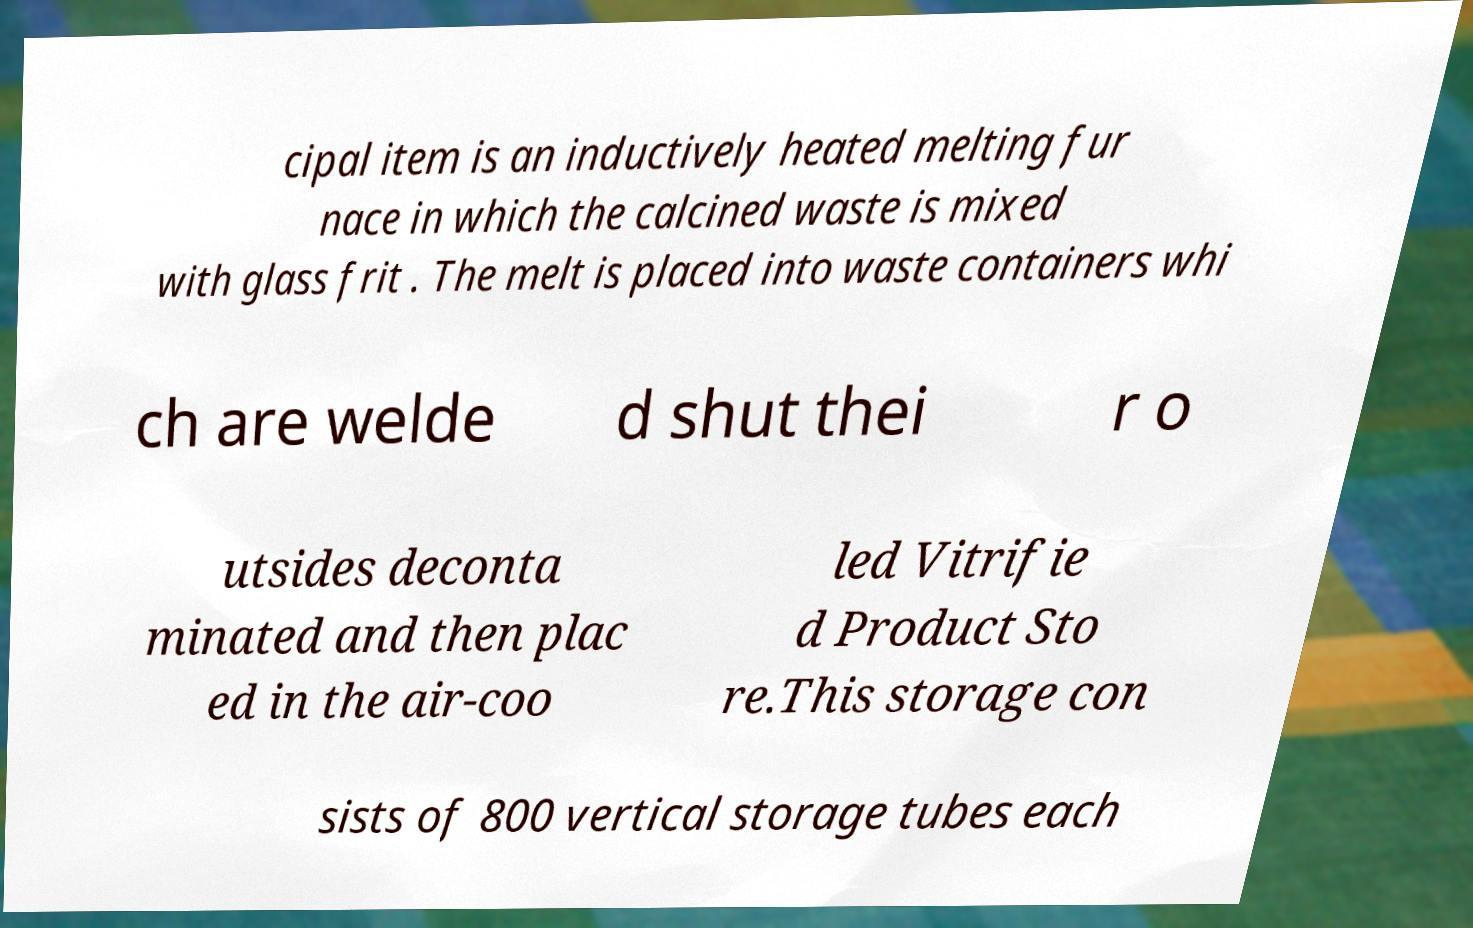For documentation purposes, I need the text within this image transcribed. Could you provide that? cipal item is an inductively heated melting fur nace in which the calcined waste is mixed with glass frit . The melt is placed into waste containers whi ch are welde d shut thei r o utsides deconta minated and then plac ed in the air-coo led Vitrifie d Product Sto re.This storage con sists of 800 vertical storage tubes each 